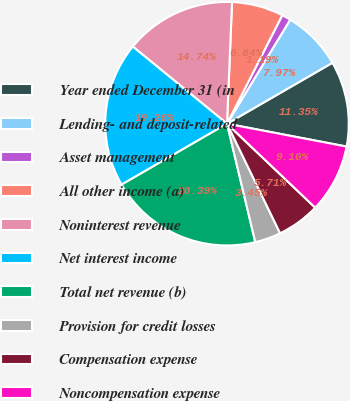<chart> <loc_0><loc_0><loc_500><loc_500><pie_chart><fcel>Year ended December 31 (in<fcel>Lending- and deposit-related<fcel>Asset management<fcel>All other income (a)<fcel>Noninterest revenue<fcel>Net interest income<fcel>Total net revenue (b)<fcel>Provision for credit losses<fcel>Compensation expense<fcel>Noncompensation expense<nl><fcel>11.35%<fcel>7.97%<fcel>1.19%<fcel>6.84%<fcel>14.74%<fcel>19.26%<fcel>20.39%<fcel>3.45%<fcel>5.71%<fcel>9.1%<nl></chart> 